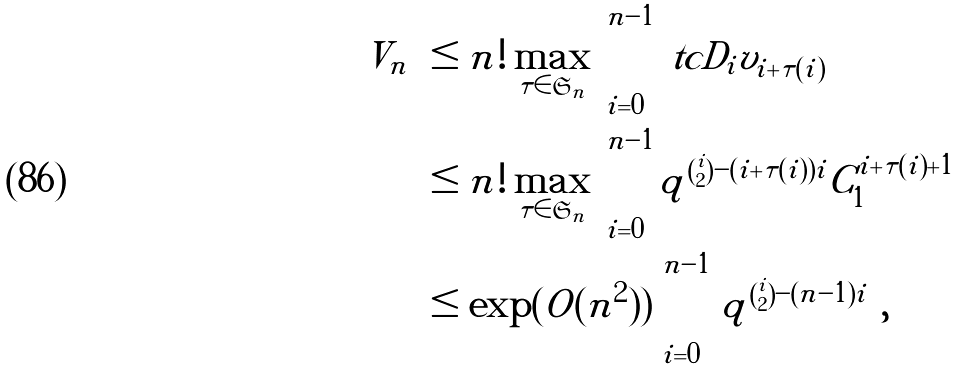<formula> <loc_0><loc_0><loc_500><loc_500>| V _ { n } | & \leq n ! \max _ { \tau \in \mathfrak S _ { n } } \prod _ { i = 0 } ^ { n - 1 } | \ t c D _ { i } v _ { i + \tau ( i ) } | \\ & \leq n ! \max _ { \tau \in \mathfrak S _ { n } } \prod _ { i = 0 } ^ { n - 1 } | q | ^ { \binom { i } { 2 } - ( i + \tau ( i ) ) i } C _ { 1 } ^ { i + \tau ( i ) + 1 } \\ & \leq \exp ( O ( n ^ { 2 } ) ) \prod _ { i = 0 } ^ { n - 1 } { | q | ^ { \binom { i } { 2 } - ( n - 1 ) i } } ,</formula> 